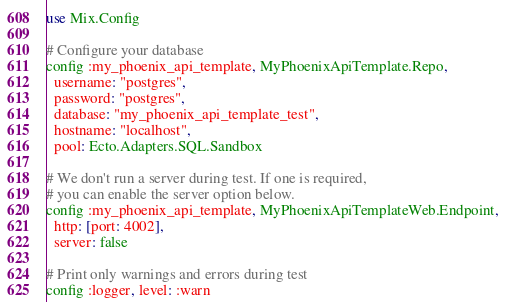<code> <loc_0><loc_0><loc_500><loc_500><_Elixir_>use Mix.Config

# Configure your database
config :my_phoenix_api_template, MyPhoenixApiTemplate.Repo,
  username: "postgres",
  password: "postgres",
  database: "my_phoenix_api_template_test",
  hostname: "localhost",
  pool: Ecto.Adapters.SQL.Sandbox

# We don't run a server during test. If one is required,
# you can enable the server option below.
config :my_phoenix_api_template, MyPhoenixApiTemplateWeb.Endpoint,
  http: [port: 4002],
  server: false

# Print only warnings and errors during test
config :logger, level: :warn
</code> 